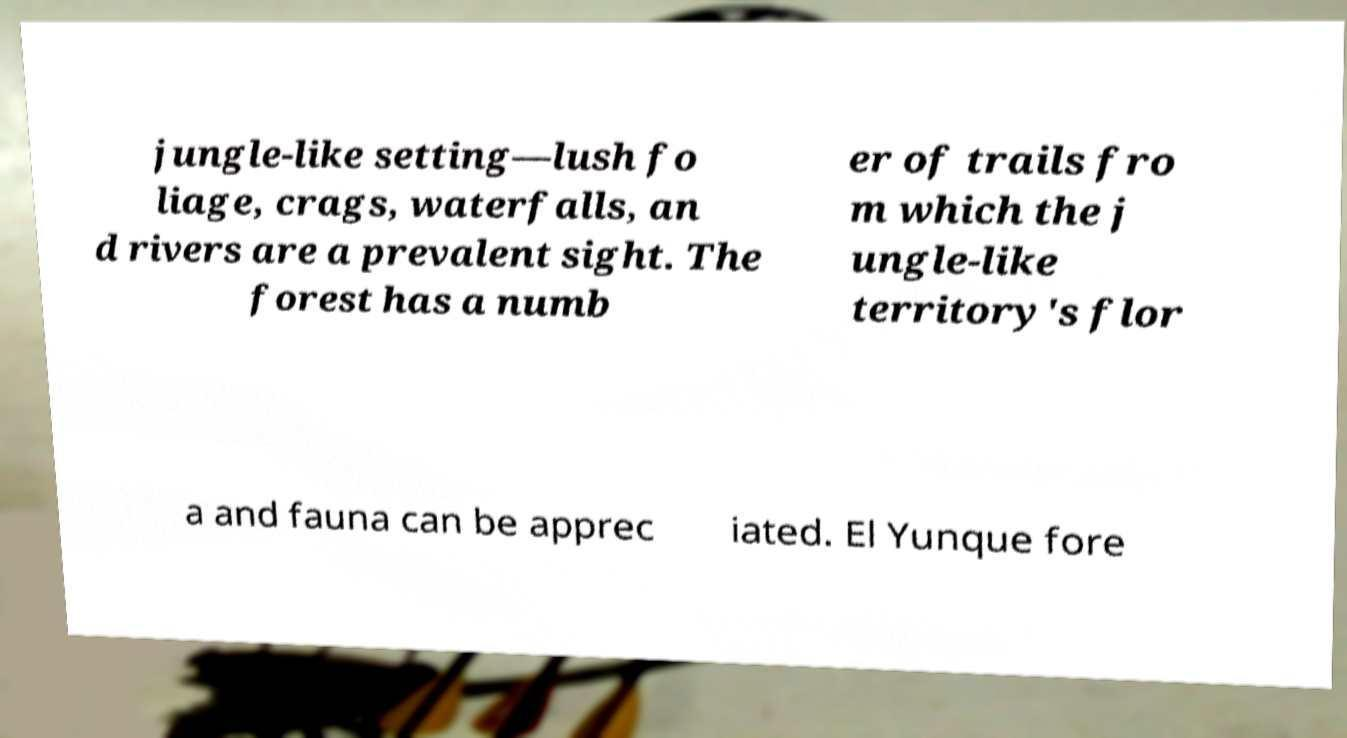There's text embedded in this image that I need extracted. Can you transcribe it verbatim? jungle-like setting—lush fo liage, crags, waterfalls, an d rivers are a prevalent sight. The forest has a numb er of trails fro m which the j ungle-like territory's flor a and fauna can be apprec iated. El Yunque fore 